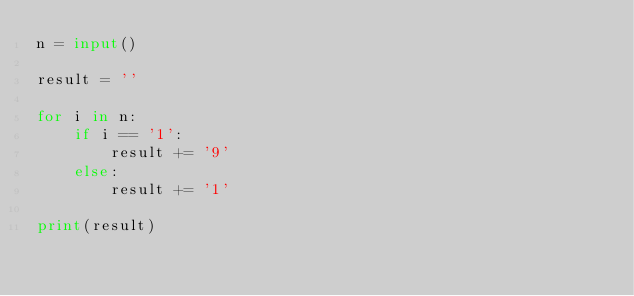<code> <loc_0><loc_0><loc_500><loc_500><_Python_>n = input()

result = ''

for i in n:
    if i == '1':
        result += '9'
    else:
        result += '1'
        
print(result)</code> 